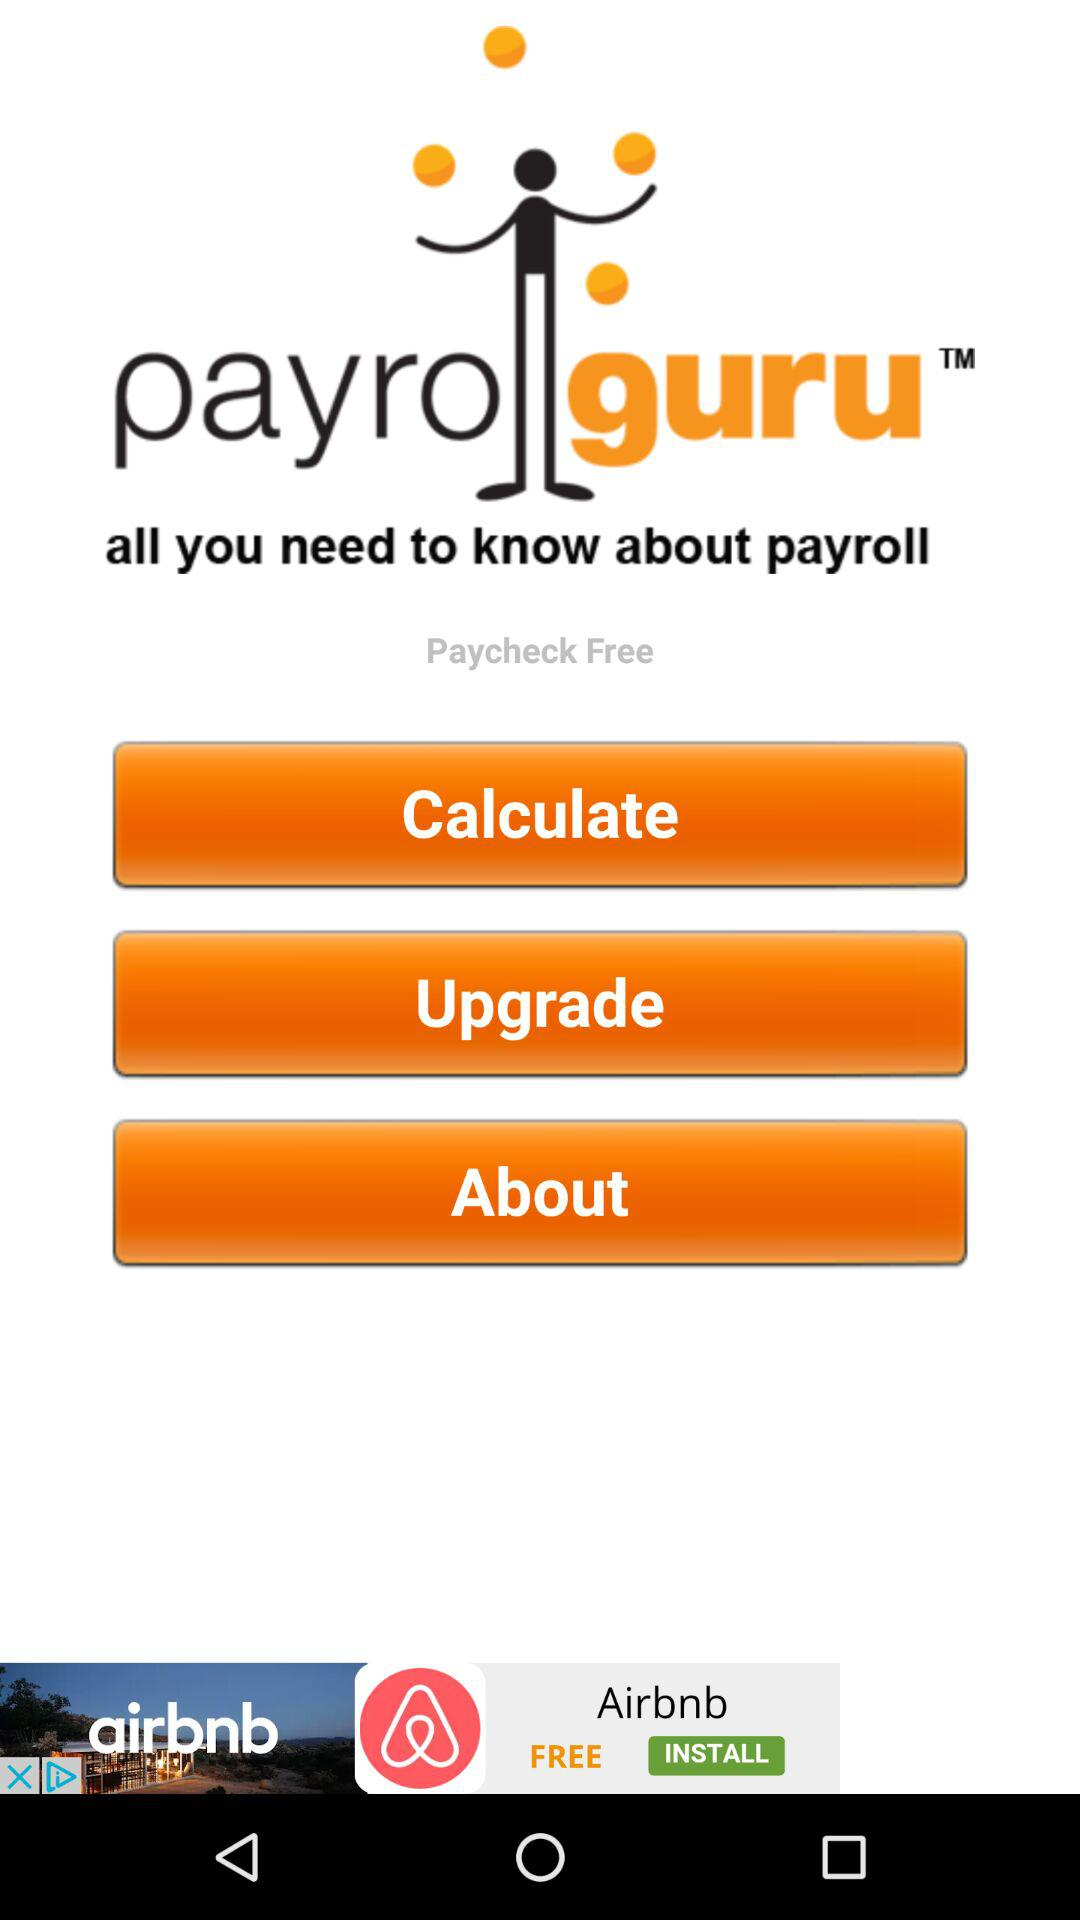What is the name of the application? The name of the application is "Paycheck Free". 